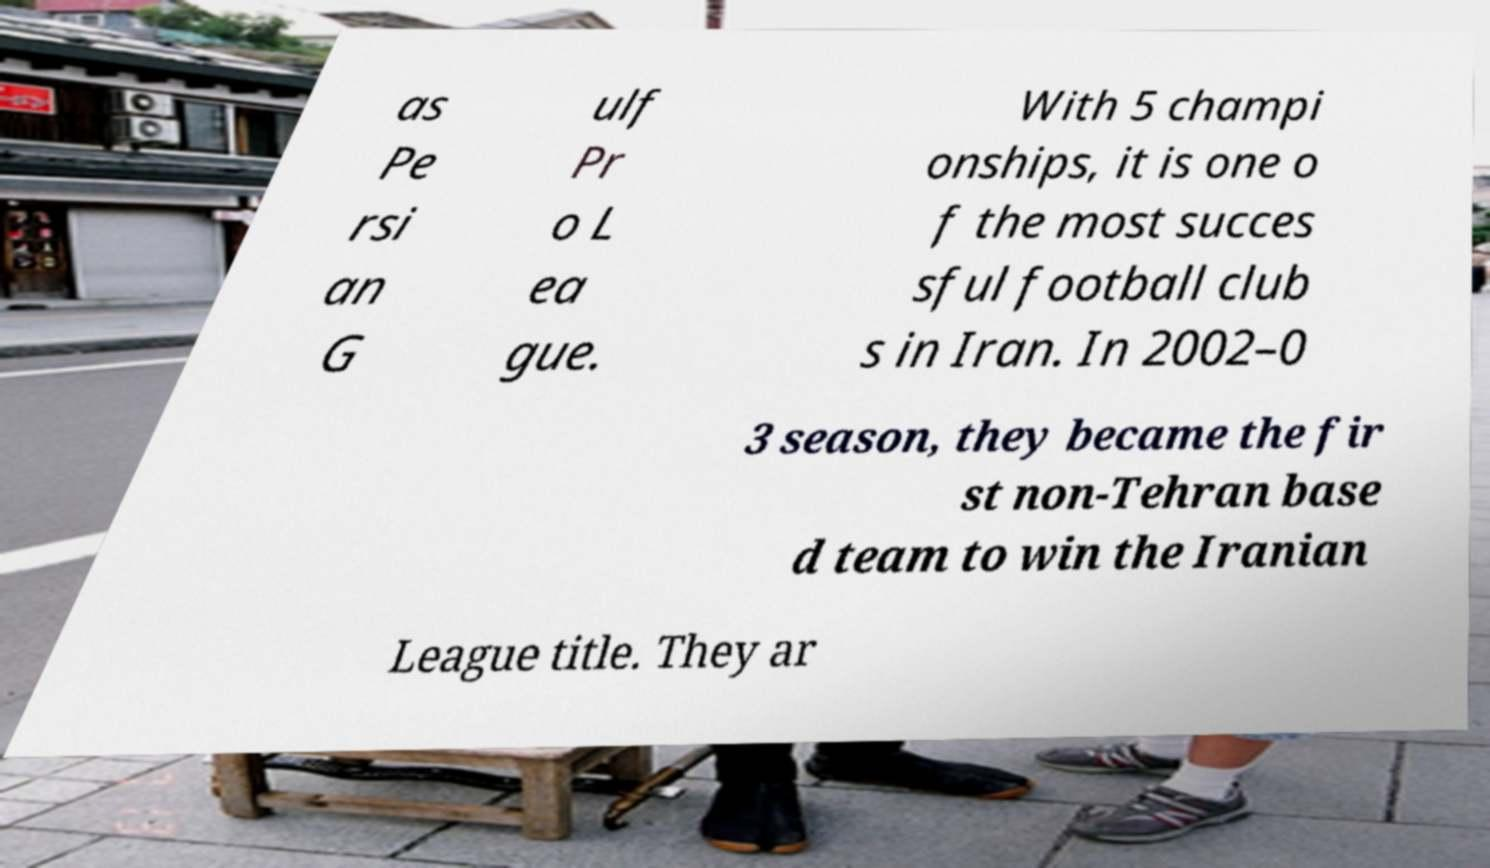Please read and relay the text visible in this image. What does it say? as Pe rsi an G ulf Pr o L ea gue. With 5 champi onships, it is one o f the most succes sful football club s in Iran. In 2002–0 3 season, they became the fir st non-Tehran base d team to win the Iranian League title. They ar 